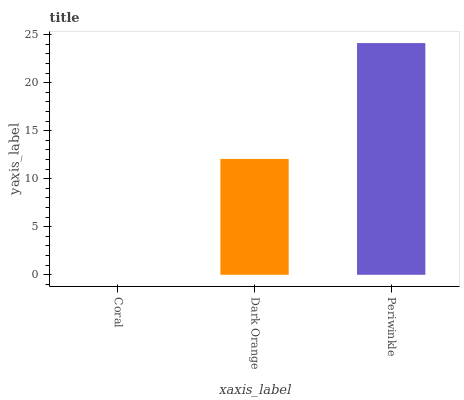Is Coral the minimum?
Answer yes or no. Yes. Is Periwinkle the maximum?
Answer yes or no. Yes. Is Dark Orange the minimum?
Answer yes or no. No. Is Dark Orange the maximum?
Answer yes or no. No. Is Dark Orange greater than Coral?
Answer yes or no. Yes. Is Coral less than Dark Orange?
Answer yes or no. Yes. Is Coral greater than Dark Orange?
Answer yes or no. No. Is Dark Orange less than Coral?
Answer yes or no. No. Is Dark Orange the high median?
Answer yes or no. Yes. Is Dark Orange the low median?
Answer yes or no. Yes. Is Periwinkle the high median?
Answer yes or no. No. Is Coral the low median?
Answer yes or no. No. 